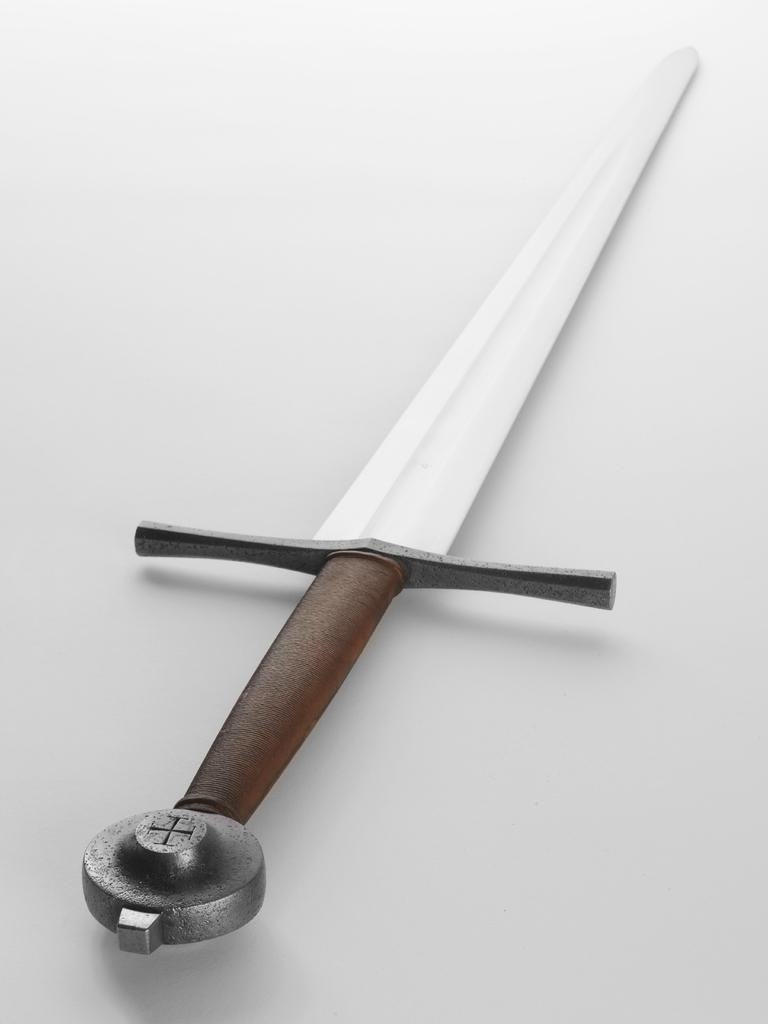What is the color of the background in the image? The background of the image is gray in color. What object is located in the middle of the image? There is a sword in the middle of the image. What class is the fireman teaching in the image? There is no fireman or class present in the image; it only features a sword in a gray background. 